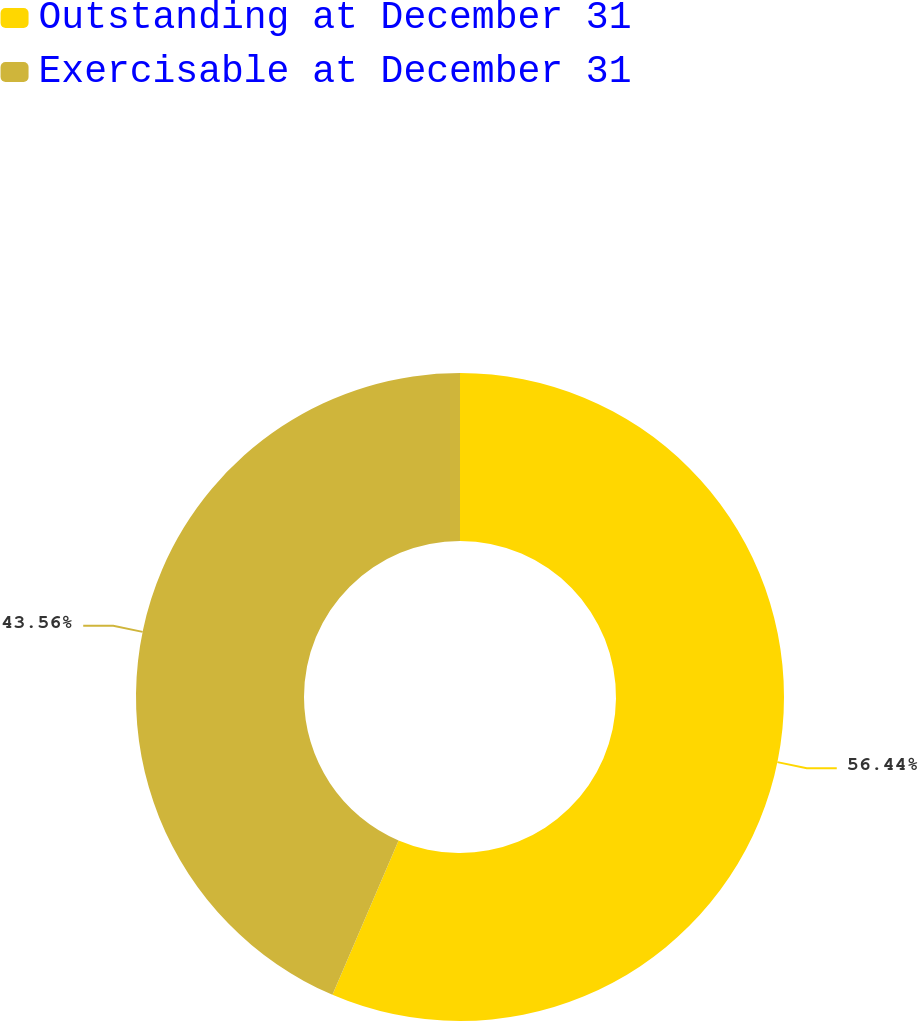Convert chart. <chart><loc_0><loc_0><loc_500><loc_500><pie_chart><fcel>Outstanding at December 31<fcel>Exercisable at December 31<nl><fcel>56.44%<fcel>43.56%<nl></chart> 